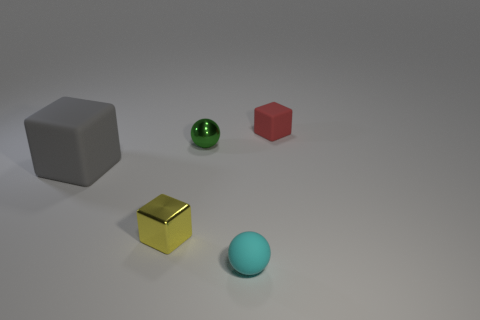Add 3 tiny cyan matte objects. How many objects exist? 8 Subtract all spheres. How many objects are left? 3 Subtract 0 gray cylinders. How many objects are left? 5 Subtract all small gray matte spheres. Subtract all large rubber objects. How many objects are left? 4 Add 2 small red matte things. How many small red matte things are left? 3 Add 1 gray matte cubes. How many gray matte cubes exist? 2 